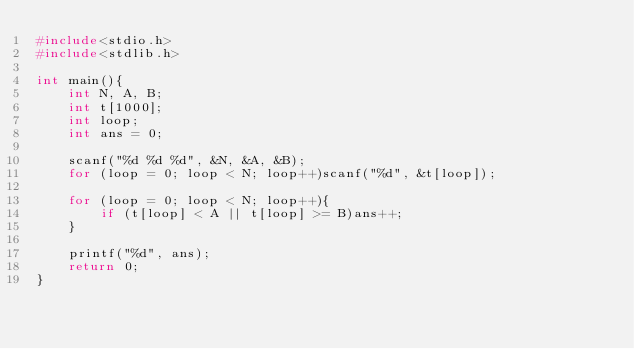<code> <loc_0><loc_0><loc_500><loc_500><_C_>#include<stdio.h>
#include<stdlib.h>

int main(){
	int N, A, B;
	int t[1000];
	int loop;
	int ans = 0;

	scanf("%d %d %d", &N, &A, &B);
	for (loop = 0; loop < N; loop++)scanf("%d", &t[loop]);

	for (loop = 0; loop < N; loop++){
		if (t[loop] < A || t[loop] >= B)ans++;
	}

	printf("%d", ans);
	return 0;
}</code> 